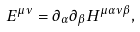Convert formula to latex. <formula><loc_0><loc_0><loc_500><loc_500>E ^ { \mu \nu } = \partial _ { \alpha } \partial _ { \beta } H ^ { \mu \alpha \nu \beta } ,</formula> 